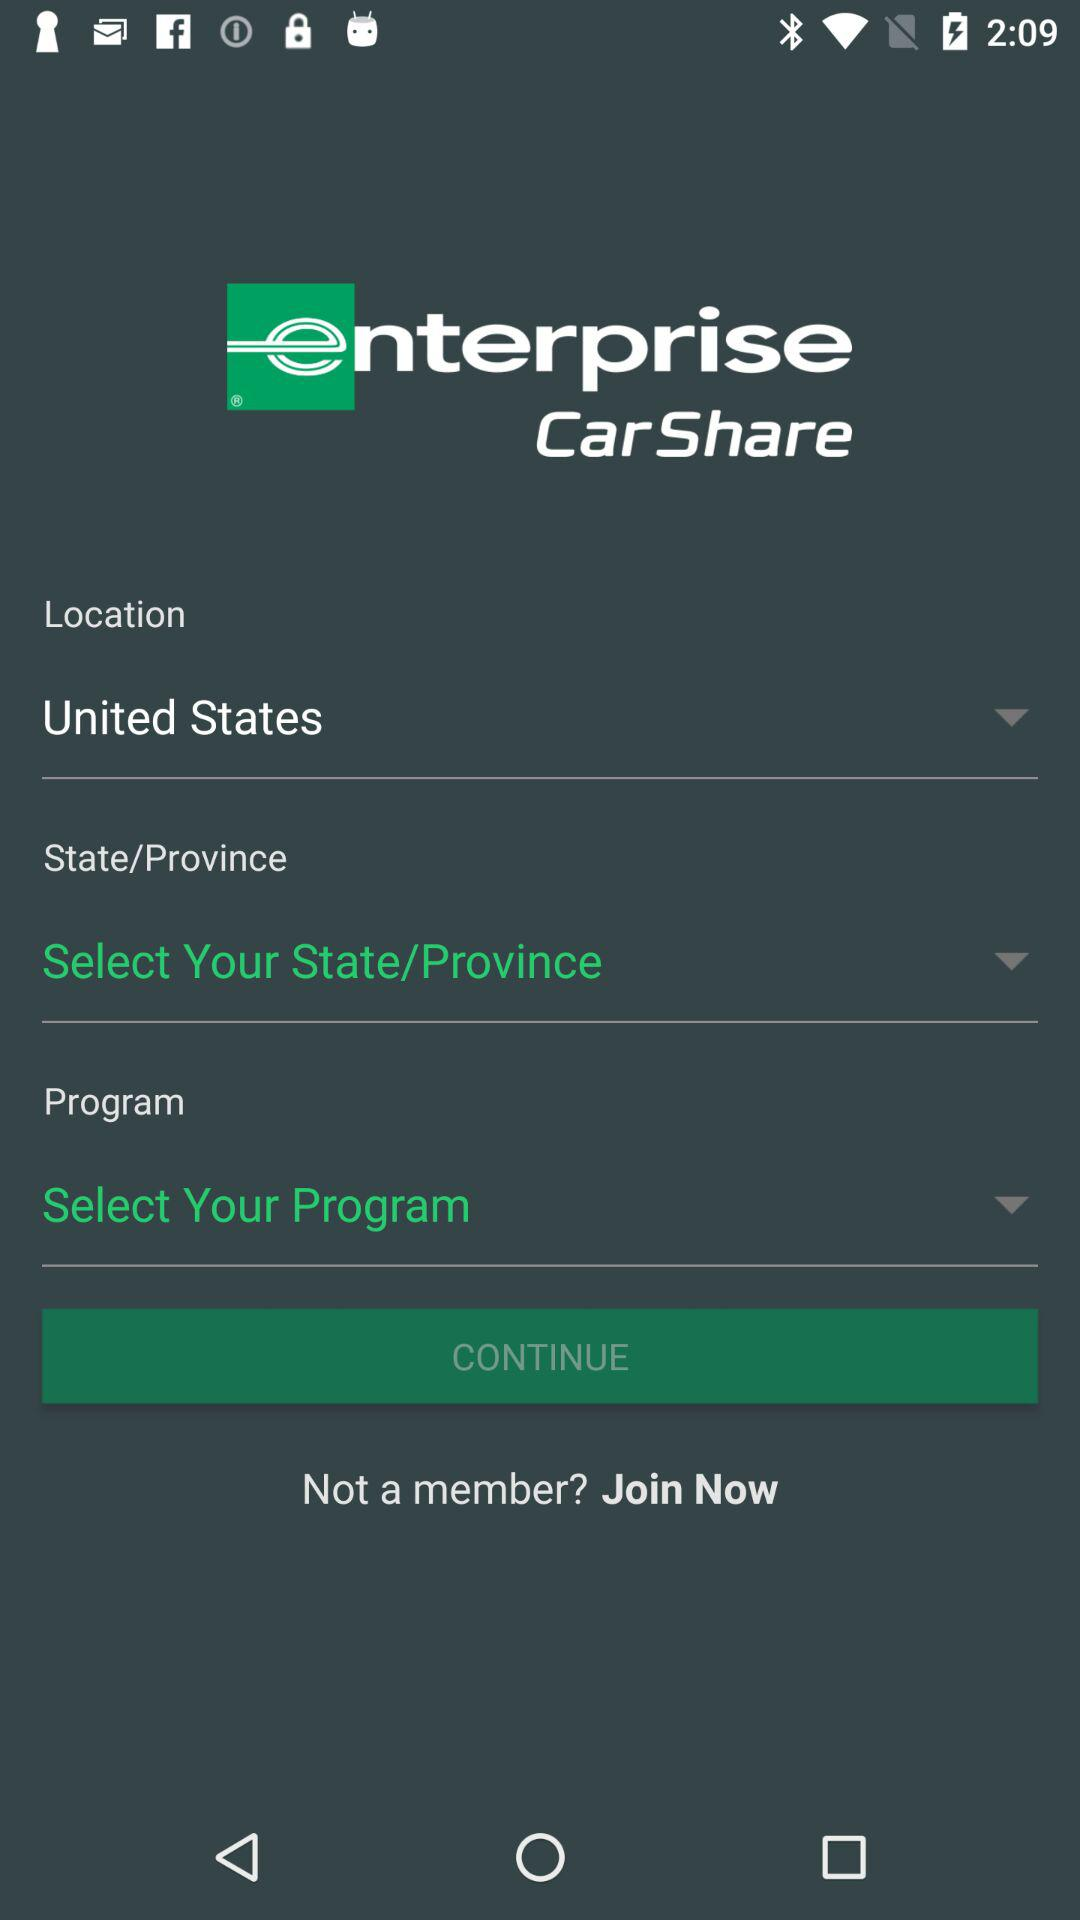What is the name of the application? The name of the application is "enterprise CarShare". 